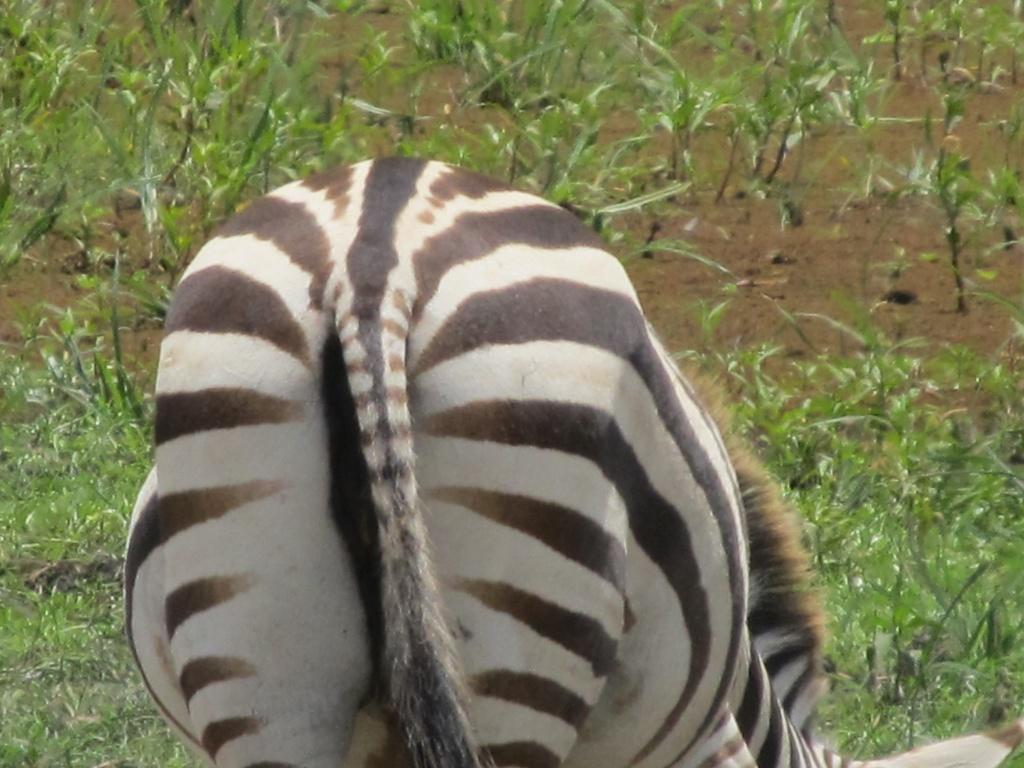What animal is present in the image? There is a zebra in the image. What is the zebra doing in the image? The zebra appears to be grazing the grass. How many hands can be seen touching the zebra in the image? There are no hands visible in the image, as it only features a zebra grazing the grass. 